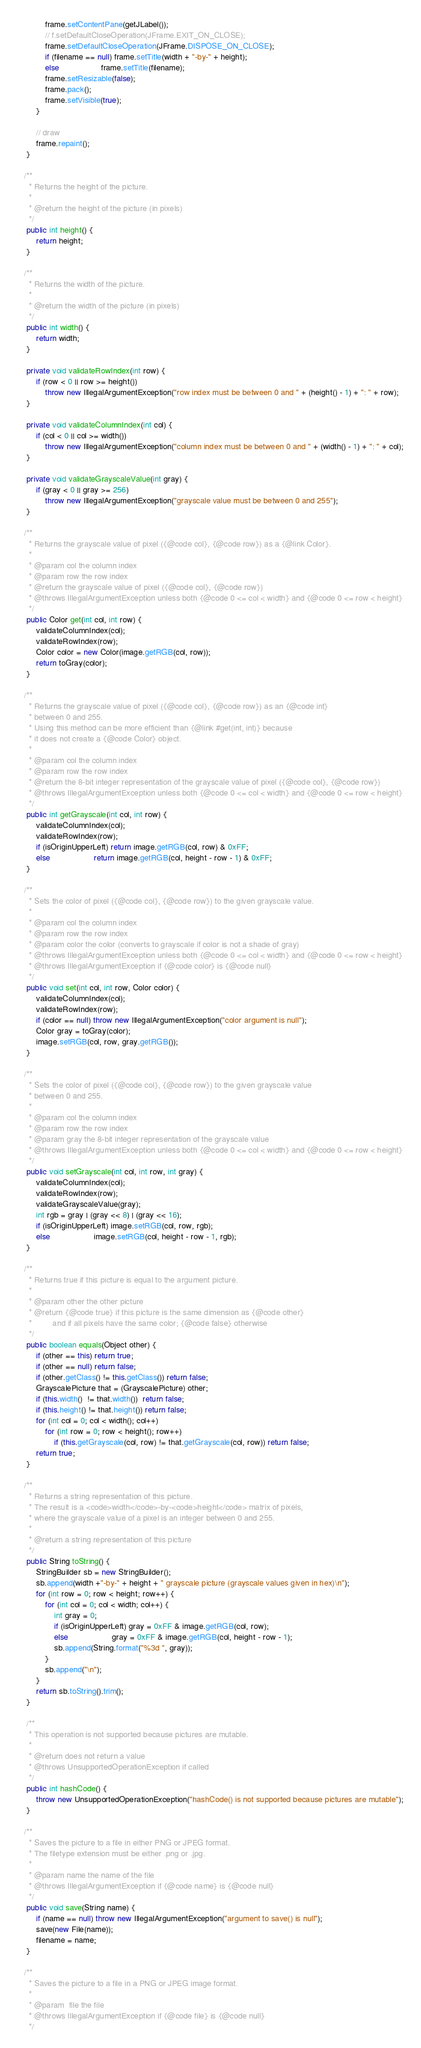<code> <loc_0><loc_0><loc_500><loc_500><_Java_>

            frame.setContentPane(getJLabel());
            // f.setDefaultCloseOperation(JFrame.EXIT_ON_CLOSE);
            frame.setDefaultCloseOperation(JFrame.DISPOSE_ON_CLOSE);
            if (filename == null) frame.setTitle(width + "-by-" + height);
            else                  frame.setTitle(filename);
            frame.setResizable(false);
            frame.pack();
            frame.setVisible(true);
        }

        // draw
        frame.repaint();
    }

   /**
     * Returns the height of the picture.
     *
     * @return the height of the picture (in pixels)
     */
    public int height() {
        return height;
    }

   /**
     * Returns the width of the picture.
     *
     * @return the width of the picture (in pixels)
     */
    public int width() {
        return width;
    }

    private void validateRowIndex(int row) {
        if (row < 0 || row >= height())
            throw new IllegalArgumentException("row index must be between 0 and " + (height() - 1) + ": " + row);
    }

    private void validateColumnIndex(int col) {
        if (col < 0 || col >= width())
            throw new IllegalArgumentException("column index must be between 0 and " + (width() - 1) + ": " + col);
    }

    private void validateGrayscaleValue(int gray) {
        if (gray < 0 || gray >= 256)
            throw new IllegalArgumentException("grayscale value must be between 0 and 255");
    }

   /**
     * Returns the grayscale value of pixel ({@code col}, {@code row}) as a {@link Color}.
     *
     * @param col the column index
     * @param row the row index
     * @return the grayscale value of pixel ({@code col}, {@code row})
     * @throws IllegalArgumentException unless both {@code 0 <= col < width} and {@code 0 <= row < height}
     */
    public Color get(int col, int row) {
        validateColumnIndex(col);
        validateRowIndex(row);
        Color color = new Color(image.getRGB(col, row));
        return toGray(color);
    }

   /**
     * Returns the grayscale value of pixel ({@code col}, {@code row}) as an {@code int}
     * between 0 and 255.
     * Using this method can be more efficient than {@link #get(int, int)} because
     * it does not create a {@code Color} object.
     *
     * @param col the column index
     * @param row the row index
     * @return the 8-bit integer representation of the grayscale value of pixel ({@code col}, {@code row})
     * @throws IllegalArgumentException unless both {@code 0 <= col < width} and {@code 0 <= row < height}
     */
    public int getGrayscale(int col, int row) {
        validateColumnIndex(col);
        validateRowIndex(row);
        if (isOriginUpperLeft) return image.getRGB(col, row) & 0xFF;
        else                   return image.getRGB(col, height - row - 1) & 0xFF;
    }

   /**
     * Sets the color of pixel ({@code col}, {@code row}) to the given grayscale value.
     *
     * @param col the column index
     * @param row the row index
     * @param color the color (converts to grayscale if color is not a shade of gray)
     * @throws IllegalArgumentException unless both {@code 0 <= col < width} and {@code 0 <= row < height}
     * @throws IllegalArgumentException if {@code color} is {@code null}
     */
    public void set(int col, int row, Color color) {
        validateColumnIndex(col);
        validateRowIndex(row);
        if (color == null) throw new IllegalArgumentException("color argument is null");
        Color gray = toGray(color);
        image.setRGB(col, row, gray.getRGB());
    }

   /**
     * Sets the color of pixel ({@code col}, {@code row}) to the given grayscale value
     * between 0 and 255.
     *
     * @param col the column index
     * @param row the row index
     * @param gray the 8-bit integer representation of the grayscale value
     * @throws IllegalArgumentException unless both {@code 0 <= col < width} and {@code 0 <= row < height}
     */
    public void setGrayscale(int col, int row, int gray) {
        validateColumnIndex(col);
        validateRowIndex(row);
        validateGrayscaleValue(gray);
        int rgb = gray | (gray << 8) | (gray << 16);
        if (isOriginUpperLeft) image.setRGB(col, row, rgb);
        else                   image.setRGB(col, height - row - 1, rgb);
    }

   /**
     * Returns true if this picture is equal to the argument picture.
     *
     * @param other the other picture
     * @return {@code true} if this picture is the same dimension as {@code other}
     *         and if all pixels have the same color; {@code false} otherwise
     */
    public boolean equals(Object other) {
        if (other == this) return true;
        if (other == null) return false;
        if (other.getClass() != this.getClass()) return false;
        GrayscalePicture that = (GrayscalePicture) other;
        if (this.width()  != that.width())  return false;
        if (this.height() != that.height()) return false;
        for (int col = 0; col < width(); col++)
            for (int row = 0; row < height(); row++)
                if (this.getGrayscale(col, row) != that.getGrayscale(col, row)) return false;
        return true;
    }

   /**
     * Returns a string representation of this picture.
     * The result is a <code>width</code>-by-<code>height</code> matrix of pixels,
     * where the grayscale value of a pixel is an integer between 0 and 255.
     *
     * @return a string representation of this picture
     */
    public String toString() {
        StringBuilder sb = new StringBuilder();
        sb.append(width +"-by-" + height + " grayscale picture (grayscale values given in hex)\n");
        for (int row = 0; row < height; row++) {
            for (int col = 0; col < width; col++) {
                int gray = 0;
                if (isOriginUpperLeft) gray = 0xFF & image.getRGB(col, row);
                else                   gray = 0xFF & image.getRGB(col, height - row - 1);
                sb.append(String.format("%3d ", gray));
            }
            sb.append("\n");
        }
        return sb.toString().trim();
    }

    /**
     * This operation is not supported because pictures are mutable.
     *
     * @return does not return a value
     * @throws UnsupportedOperationException if called
     */
    public int hashCode() {
        throw new UnsupportedOperationException("hashCode() is not supported because pictures are mutable");
    }

   /**
     * Saves the picture to a file in either PNG or JPEG format.
     * The filetype extension must be either .png or .jpg.
     *
     * @param name the name of the file
     * @throws IllegalArgumentException if {@code name} is {@code null}
     */
    public void save(String name) {
        if (name == null) throw new IllegalArgumentException("argument to save() is null");
        save(new File(name));
        filename = name;
    }

   /**
     * Saves the picture to a file in a PNG or JPEG image format.
     *
     * @param  file the file
     * @throws IllegalArgumentException if {@code file} is {@code null}
     */</code> 